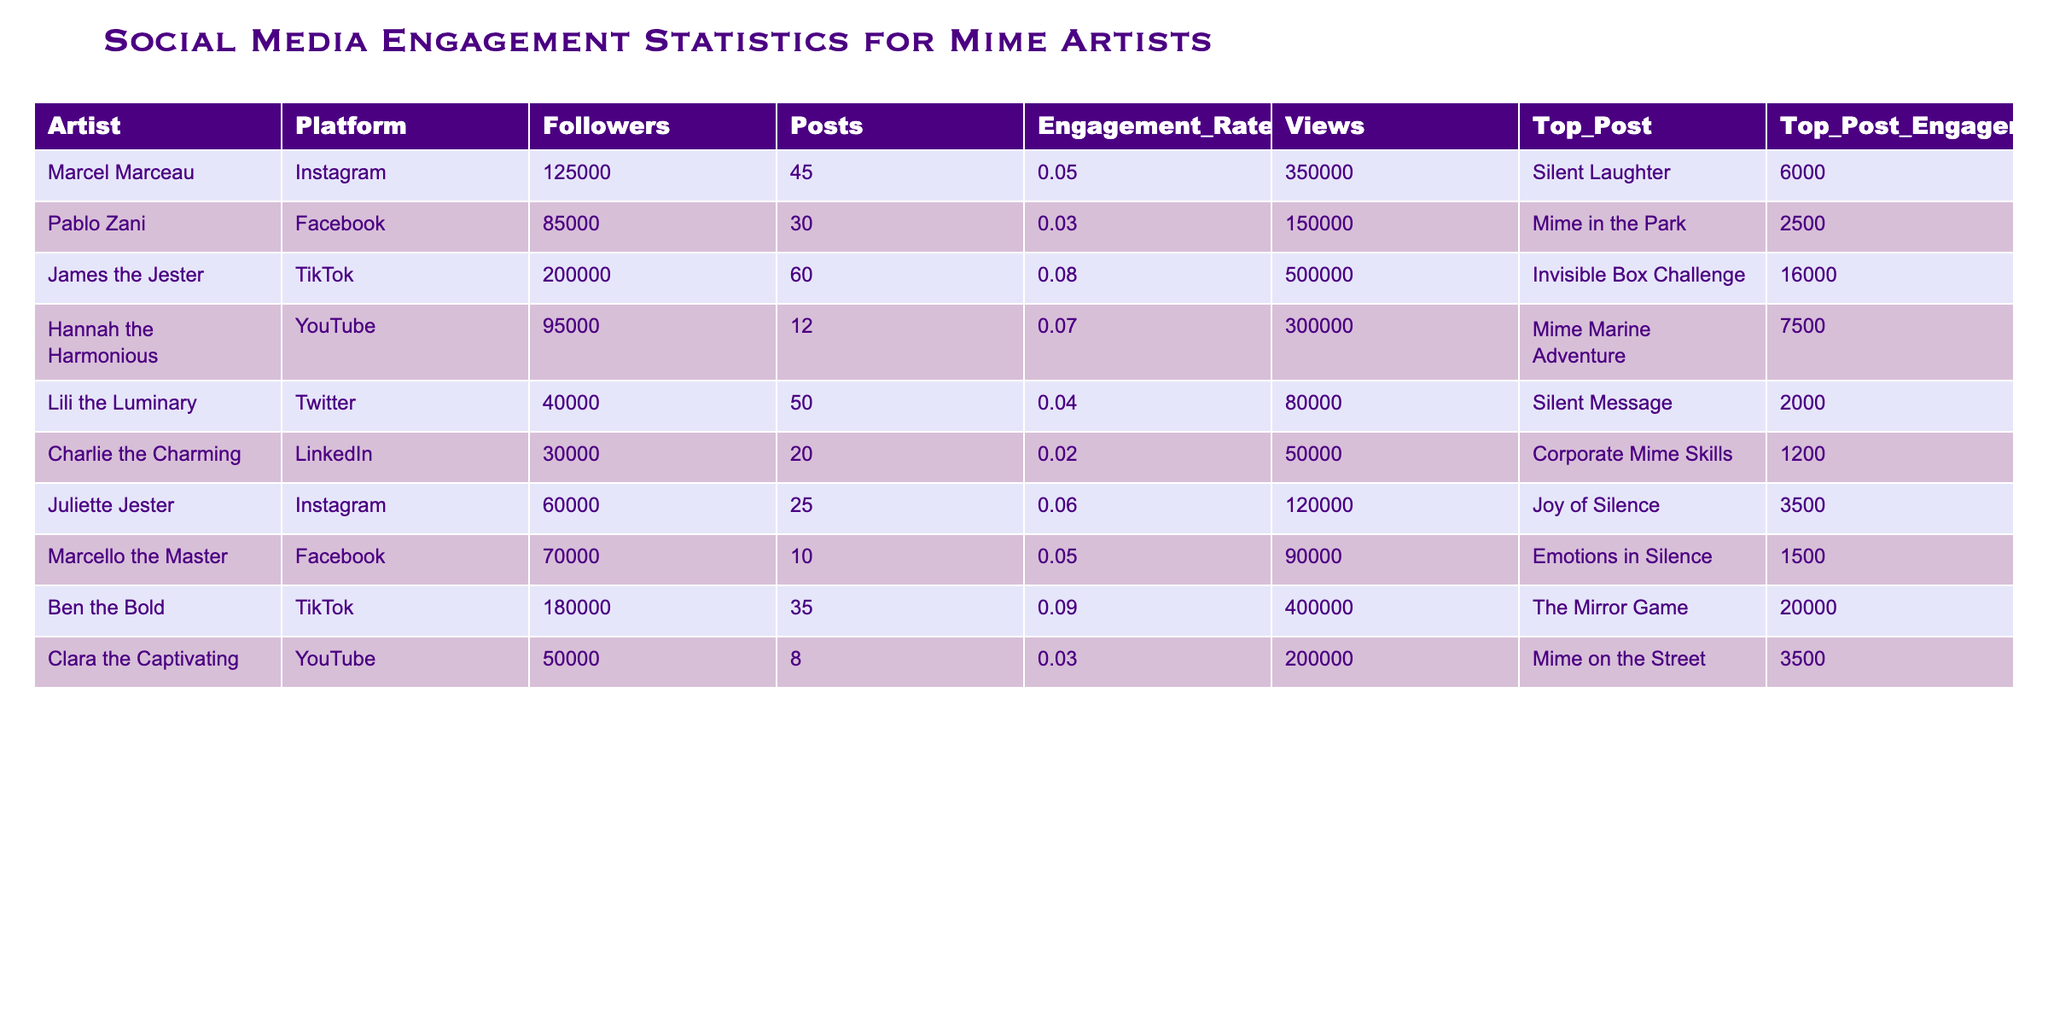What is the highest engagement rate among the artists? The table shows engagement rates for each artist. The highest engagement rate is 0.09 for Ben the Bold.
Answer: 0.09 Which artist has the most followers on TikTok? According to the table, James the Jester has the most followers on TikTok with 200,000 followers.
Answer: James the Jester What is the total number of posts made by artists on Instagram? Marcel Marceau made 45 posts and Juliette Jester made 25 posts on Instagram. Therefore, the total number of posts is 45 + 25 = 70.
Answer: 70 Is Clara the Captivating's top post engagement higher than Hannah the Harmonious's? Clara the Captivating's top post engagement is 3,500 while Hannah the Harmonious's is 7,500. This means Clara's engagement is lower than Hannah's.
Answer: No What is the average number of followers of all the artists listed? First, sum all the followers: 125000 + 85000 + 200000 + 95000 + 40000 + 30000 + 60000 + 70000 + 180000 + 50000 =  1030000. There are 10 artists, so the average is 1030000 / 10 = 103000.
Answer: 103000 Which artist had the top post with the least engagement across all platforms? By checking the top post engagement, Charlie the Charming has the least at 1,200.
Answer: Charlie the Charming What is the difference in views between James the Jester's and Ben the Bold's posts? James the Jester's views are 500,000 and Ben the Bold's are 400,000. The difference is 500,000 - 400,000 = 100,000.
Answer: 100000 Which platform has the most total followers combined from all artists? Adding the followers: Instagram (125000 + 60000) + Facebook (85000 + 70000) + TikTok (200000 + 180000) + YouTube (95000 + 50000) + Twitter (40000) + LinkedIn (30000) = 1,030,000 total followers. TikTok has the most individual counts, but combined it's still 1,030,000.
Answer: 1030000 Has any artist engaged more than 10,000 in their top post? James the Jester and Ben the Bold both have top post engagements above 10,000 (16,000 and 20,000 respectively).
Answer: Yes What percentage of total views does Hannah the Harmonious generate compared to the total views of all artists? The total views are: 350000 + 150000 + 500000 + 300000 + 80000 + 50000 + 120000 + 90000 + 400000 + 200000 = 2,200,000. Hannah's views are 350,000, so the percentage is (350,000 / 2,200,000) * 100 = 15.91%.
Answer: 15.91% 